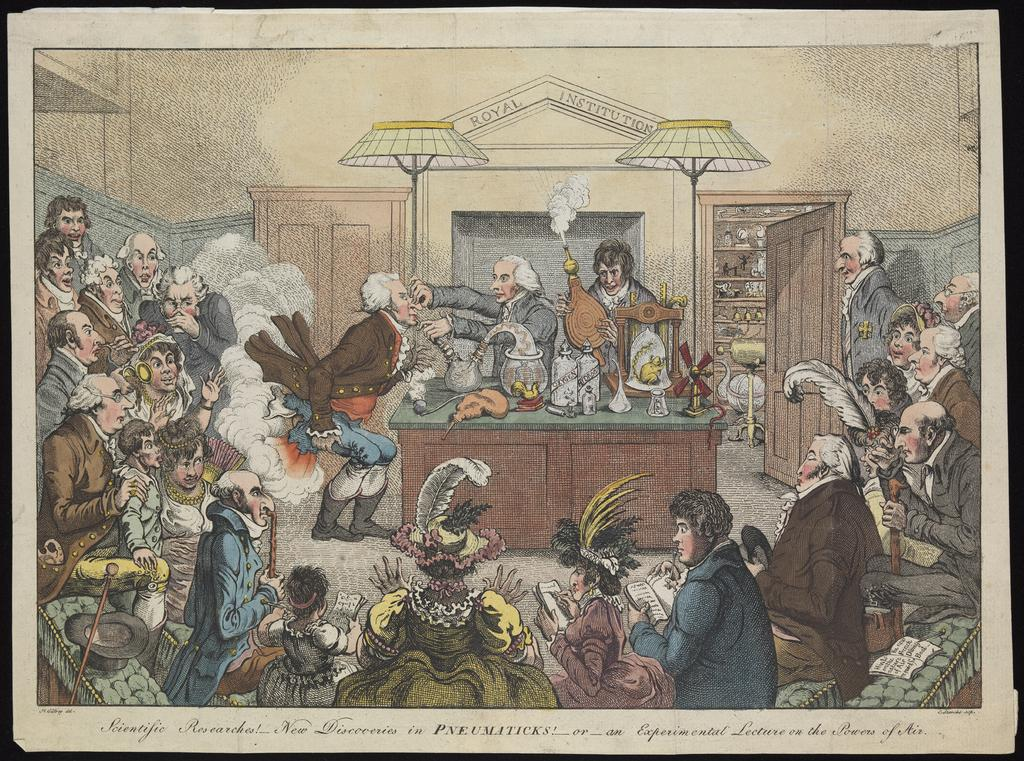<image>
Describe the image concisely. Drawing of politicans having a meeting and the word "Pneumaticks" on the bottom. 